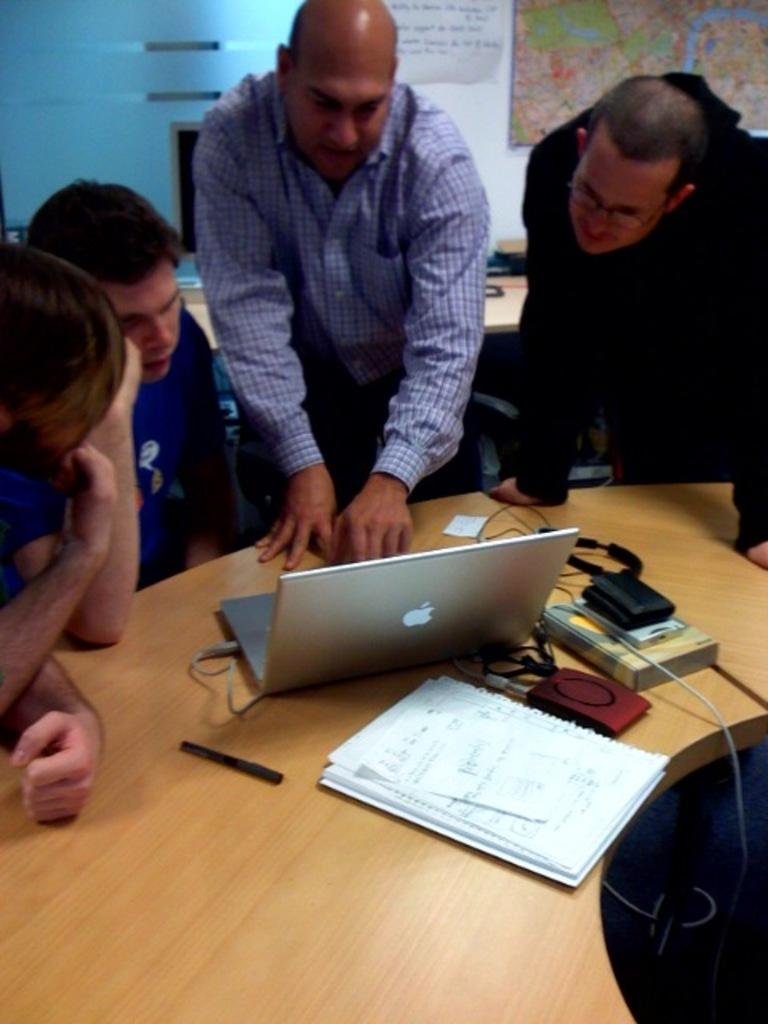How many people are present in the image? There are four people standing in the image. What objects can be seen on the table in the image? There is a laptop, a book, a pen, and a charger board on the table. What type of quill is being used to write on the book in the image? There is no quill present in the image; instead, a pen is visible on the table. What type of minister is present in the image? There is no minister present in the image; the focus is on the four people standing and the objects on the table. 